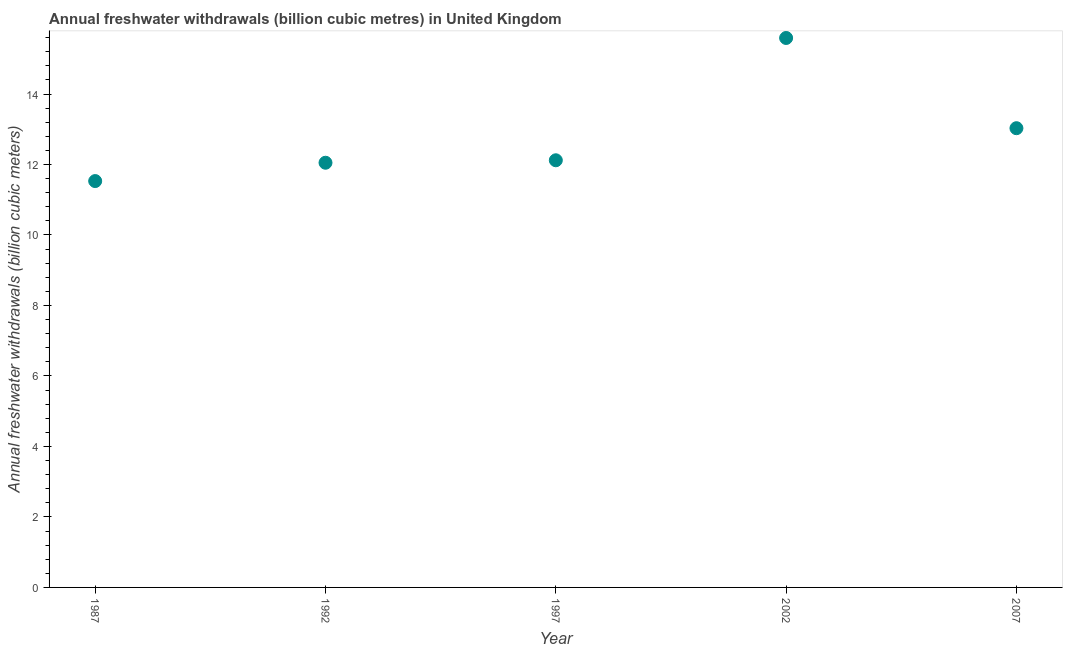What is the annual freshwater withdrawals in 1992?
Keep it short and to the point. 12.05. Across all years, what is the maximum annual freshwater withdrawals?
Provide a short and direct response. 15.59. Across all years, what is the minimum annual freshwater withdrawals?
Ensure brevity in your answer.  11.53. In which year was the annual freshwater withdrawals maximum?
Your response must be concise. 2002. What is the sum of the annual freshwater withdrawals?
Give a very brief answer. 64.32. What is the average annual freshwater withdrawals per year?
Ensure brevity in your answer.  12.86. What is the median annual freshwater withdrawals?
Give a very brief answer. 12.12. What is the ratio of the annual freshwater withdrawals in 2002 to that in 2007?
Provide a short and direct response. 1.2. What is the difference between the highest and the second highest annual freshwater withdrawals?
Make the answer very short. 2.56. Is the sum of the annual freshwater withdrawals in 1997 and 2007 greater than the maximum annual freshwater withdrawals across all years?
Your answer should be compact. Yes. What is the difference between the highest and the lowest annual freshwater withdrawals?
Provide a succinct answer. 4.06. In how many years, is the annual freshwater withdrawals greater than the average annual freshwater withdrawals taken over all years?
Your response must be concise. 2. Does the annual freshwater withdrawals monotonically increase over the years?
Your answer should be compact. No. How many dotlines are there?
Your answer should be compact. 1. Does the graph contain any zero values?
Your response must be concise. No. What is the title of the graph?
Keep it short and to the point. Annual freshwater withdrawals (billion cubic metres) in United Kingdom. What is the label or title of the Y-axis?
Make the answer very short. Annual freshwater withdrawals (billion cubic meters). What is the Annual freshwater withdrawals (billion cubic meters) in 1987?
Give a very brief answer. 11.53. What is the Annual freshwater withdrawals (billion cubic meters) in 1992?
Offer a terse response. 12.05. What is the Annual freshwater withdrawals (billion cubic meters) in 1997?
Give a very brief answer. 12.12. What is the Annual freshwater withdrawals (billion cubic meters) in 2002?
Provide a short and direct response. 15.59. What is the Annual freshwater withdrawals (billion cubic meters) in 2007?
Provide a succinct answer. 13.03. What is the difference between the Annual freshwater withdrawals (billion cubic meters) in 1987 and 1992?
Offer a terse response. -0.52. What is the difference between the Annual freshwater withdrawals (billion cubic meters) in 1987 and 1997?
Give a very brief answer. -0.59. What is the difference between the Annual freshwater withdrawals (billion cubic meters) in 1987 and 2002?
Provide a short and direct response. -4.06. What is the difference between the Annual freshwater withdrawals (billion cubic meters) in 1992 and 1997?
Keep it short and to the point. -0.07. What is the difference between the Annual freshwater withdrawals (billion cubic meters) in 1992 and 2002?
Keep it short and to the point. -3.54. What is the difference between the Annual freshwater withdrawals (billion cubic meters) in 1992 and 2007?
Your answer should be very brief. -0.98. What is the difference between the Annual freshwater withdrawals (billion cubic meters) in 1997 and 2002?
Provide a short and direct response. -3.47. What is the difference between the Annual freshwater withdrawals (billion cubic meters) in 1997 and 2007?
Your answer should be very brief. -0.91. What is the difference between the Annual freshwater withdrawals (billion cubic meters) in 2002 and 2007?
Keep it short and to the point. 2.56. What is the ratio of the Annual freshwater withdrawals (billion cubic meters) in 1987 to that in 1997?
Give a very brief answer. 0.95. What is the ratio of the Annual freshwater withdrawals (billion cubic meters) in 1987 to that in 2002?
Provide a succinct answer. 0.74. What is the ratio of the Annual freshwater withdrawals (billion cubic meters) in 1987 to that in 2007?
Keep it short and to the point. 0.89. What is the ratio of the Annual freshwater withdrawals (billion cubic meters) in 1992 to that in 2002?
Make the answer very short. 0.77. What is the ratio of the Annual freshwater withdrawals (billion cubic meters) in 1992 to that in 2007?
Provide a succinct answer. 0.93. What is the ratio of the Annual freshwater withdrawals (billion cubic meters) in 1997 to that in 2002?
Keep it short and to the point. 0.78. What is the ratio of the Annual freshwater withdrawals (billion cubic meters) in 1997 to that in 2007?
Make the answer very short. 0.93. What is the ratio of the Annual freshwater withdrawals (billion cubic meters) in 2002 to that in 2007?
Keep it short and to the point. 1.2. 